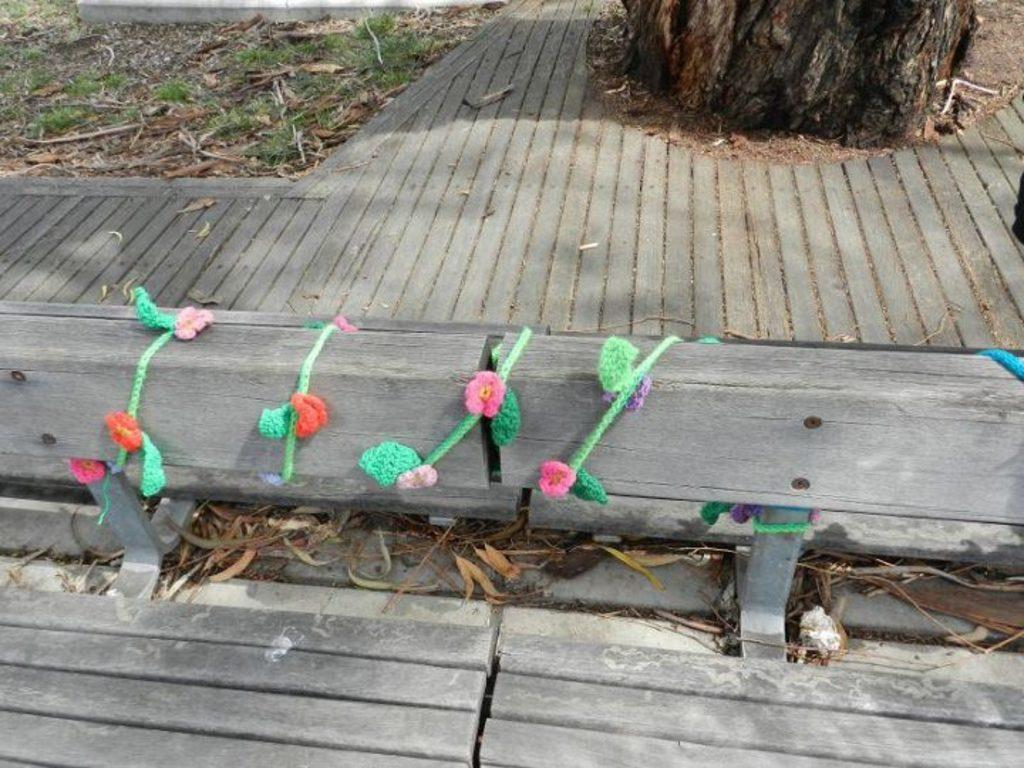What is the main object in the image? There is a wooden log in the image. What is wrapped around the wooden log? A color rope is wound around the wooden log. What type of surface can be seen in the image? There is a wooden surface in the image. What type of vegetation is present in the image? Dry grass is present in the image. What is the natural setting visible in the image? Grass is visible in the image. What other wooden object can be seen in the image? There is a tree trunk in the image. What type of toy can be seen playing with the wooden log in the image? There is no toy present in the image, and therefore no such activity can be observed. 